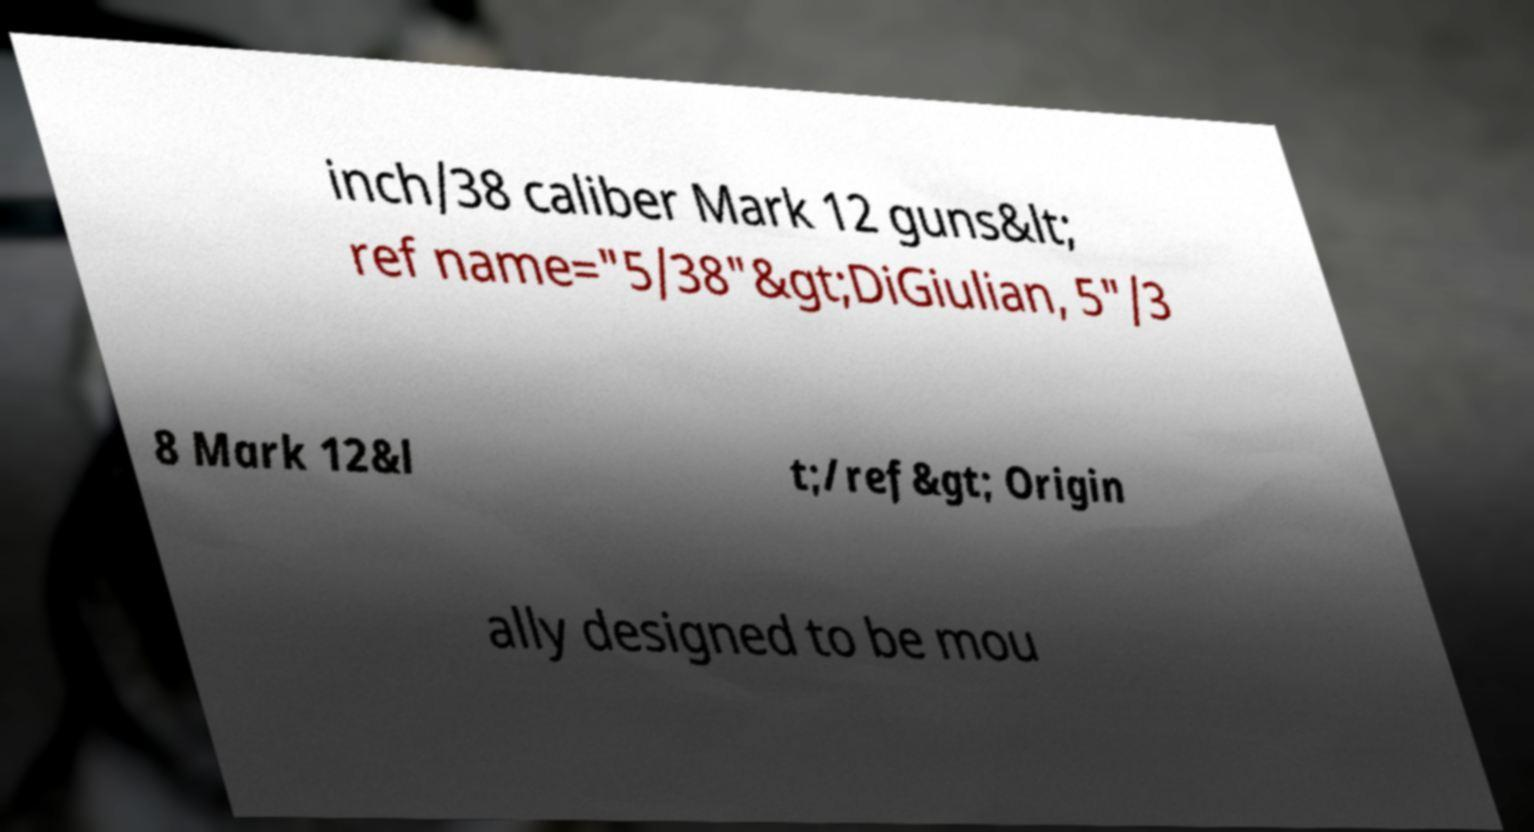Can you accurately transcribe the text from the provided image for me? inch/38 caliber Mark 12 guns&lt; ref name="5/38"&gt;DiGiulian, 5"/3 8 Mark 12&l t;/ref&gt; Origin ally designed to be mou 